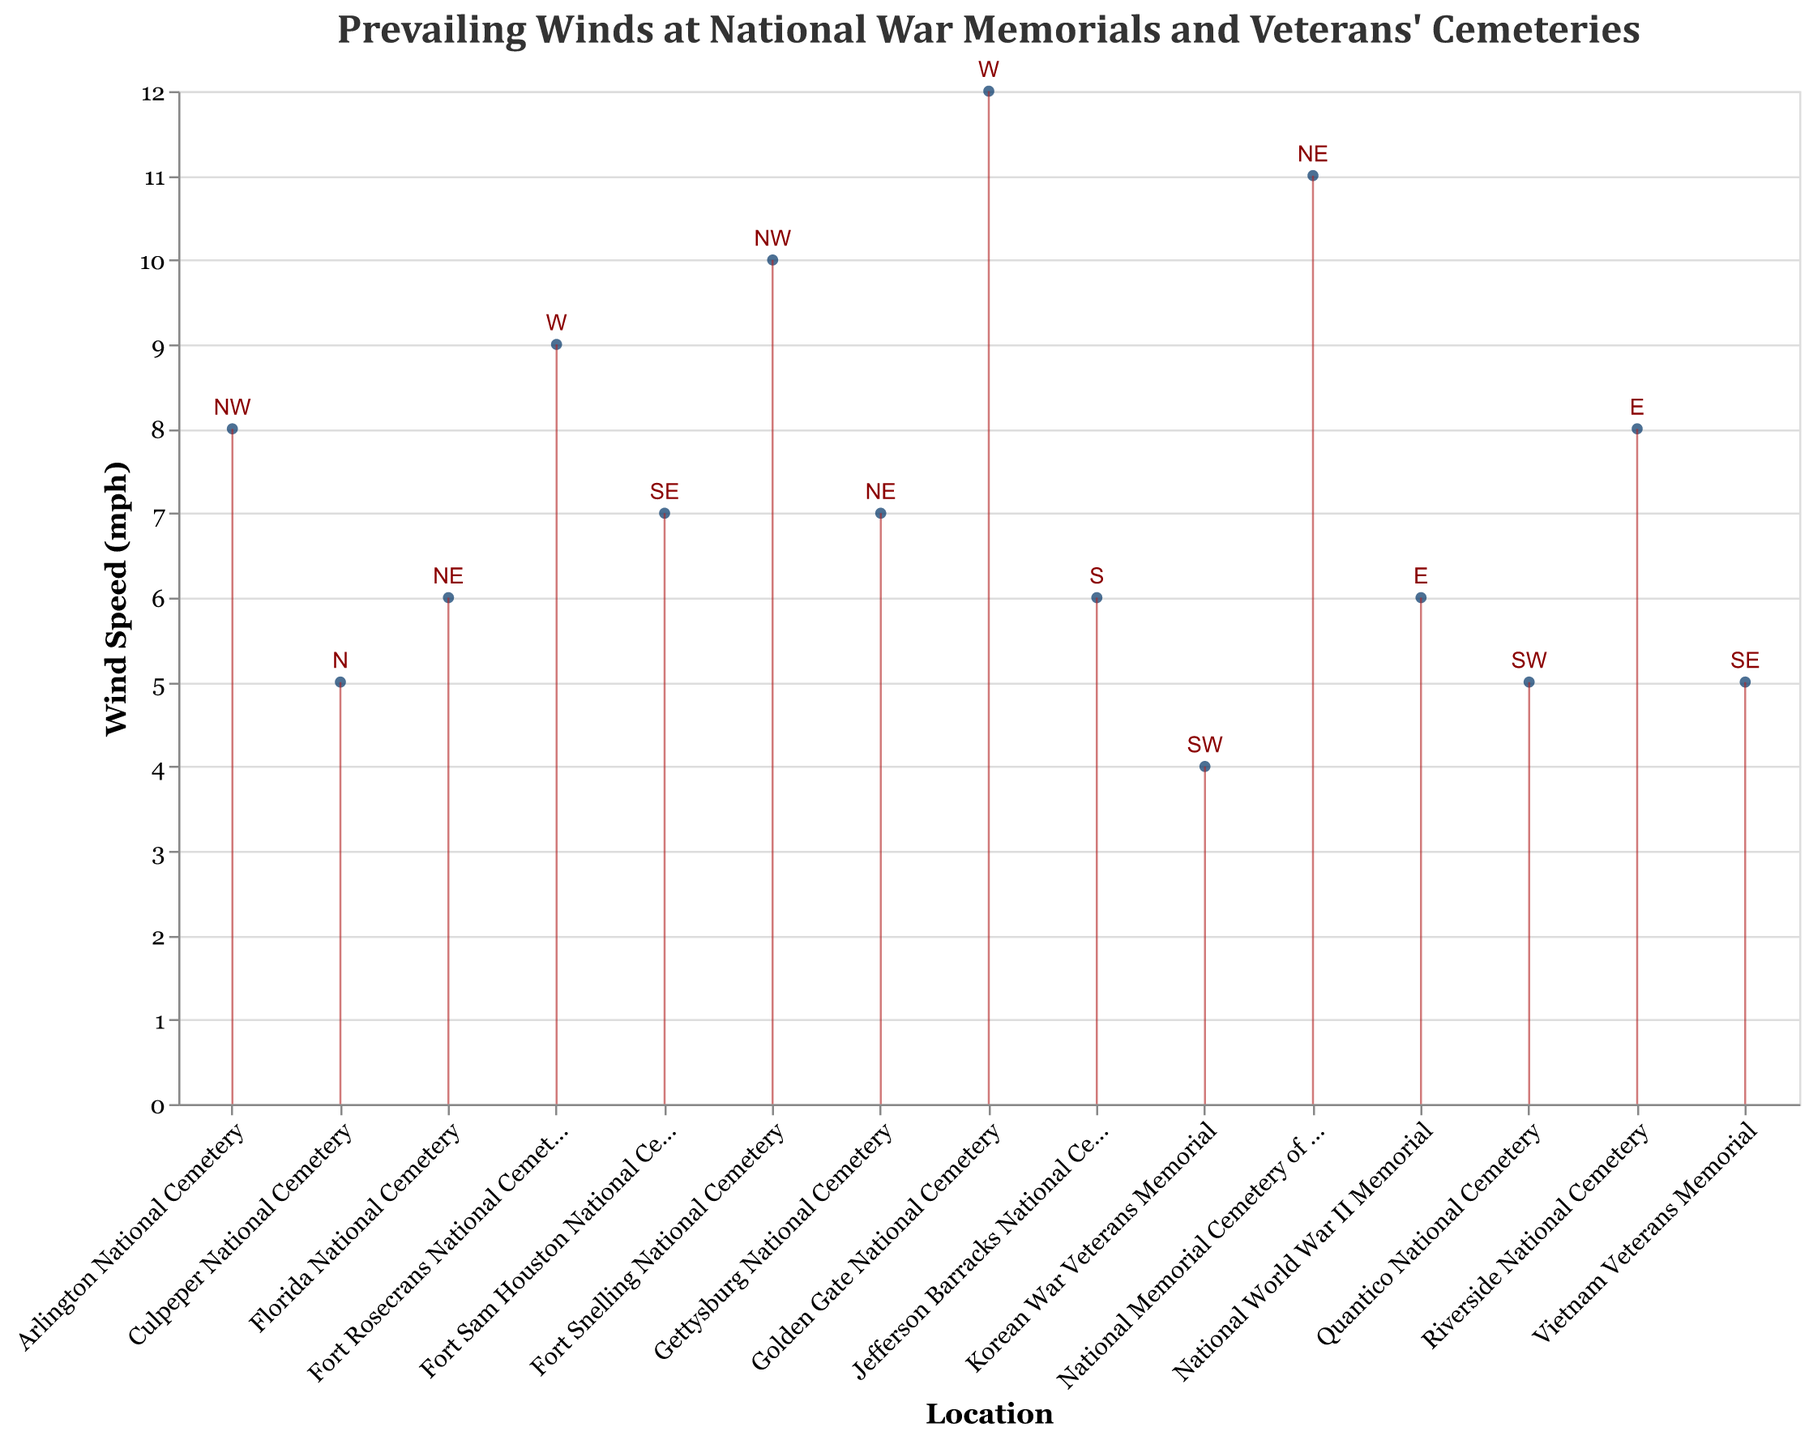What's the average wind speed at the national war memorials and veterans' cemeteries? To find the average wind speed, add up all the wind speeds from each location and divide by the total number of locations. The wind speeds are: 8, 5, 6, 4, 7, 9, 11, 10, 6, 8, 5, 7, 12, 6, and 5, totaling 109 mph. There are 15 locations, so the average wind speed is 109/15.
Answer: 7.27 mph Which location has the highest wind speed and what is it? The data shows that Golden Gate National Cemetery has the highest wind speed of 12 mph.
Answer: Golden Gate National Cemetery, 12 mph Which direction does the prevailing wind come from at Arlington National Cemetery? The map indicates that the prevailing wind direction at Arlington National Cemetery is NW.
Answer: NW How many locations have a wind speed greater than 8 mph? Reviewing the wind speeds, 3 locations have wind speeds greater than 8 mph: National Memorial Cemetery of the Pacific (11 mph), Fort Snelling National Cemetery (10 mph), and Golden Gate National Cemetery (12 mph).
Answer: 3 What is the difference in wind speed between Riverside National Cemetery and the Korean War Veterans Memorial? Riverside National Cemetery has a wind speed of 8 mph while the Korean War Veterans Memorial has a speed of 4 mph. The difference is 8 - 4.
Answer: 4 mph Identify the locations where the wind direction is NE. The locations with NE wind direction are Gettysburg National Cemetery, National Memorial Cemetery of the Pacific, and Florida National Cemetery.
Answer: Gettysburg National Cemetery, National Memorial Cemetery of the Pacific, Florida National Cemetery Which locations have a wind speed less than 6 mph, and what are their prevailing wind directions? Vietnam Veterans Memorial (SE, 5 mph), Korean War Veterans Memorial (SW, 4 mph), Culpeper National Cemetery (N, 5 mph), and Quantico National Cemetery (SW, 5 mph) all have wind speeds less than 6 mph. The corresponding directions are SE, SW, N, and SW.
Answer: Vietnam Veterans Memorial (SE), Korean War Veterans Memorial (SW), Culpeper National Cemetery (N), Quantico National Cemetery (SW) How many locations have prevailing wind directions coming from the west (W)? List these locations. The locations with prevailing wind directions from the west include Fort Rosecrans National Cemetery and Golden Gate National Cemetery.
Answer: 2 (Fort Rosecrans National Cemetery, Golden Gate National Cemetery) Which memorial has the least wind speed, and what is its direction? The Korean War Veterans Memorial has the least wind speed of 4 mph, and the direction is SW.
Answer: Korean War Veterans Memorial, SW Compare the wind speed at Fort Snelling National Cemetery and Fort Sam Houston National Cemetery. Which location has a higher wind speed and by how much? Fort Snelling National Cemetery has a wind speed of 10 mph, and Fort Sam Houston National Cemetery has a wind speed of 7 mph. Fort Snelling has a higher wind speed by 3 mph.
Answer: Fort Snelling National Cemetery, 3 mph 